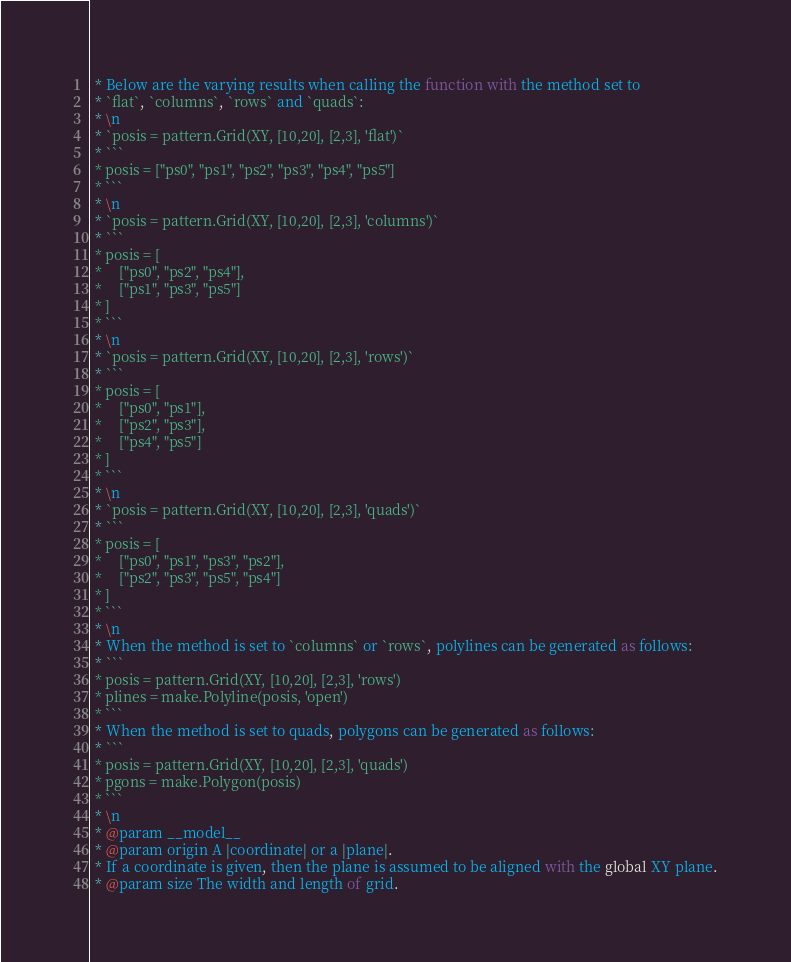<code> <loc_0><loc_0><loc_500><loc_500><_JavaScript_> * Below are the varying results when calling the function with the method set to
 * `flat`, `columns`, `rows` and `quads`:
 * \n
 * `posis = pattern.Grid(XY, [10,20], [2,3], 'flat')`
 * ```
 * posis = ["ps0", "ps1", "ps2", "ps3", "ps4", "ps5"]
 * ```
 * \n
 * `posis = pattern.Grid(XY, [10,20], [2,3], 'columns')`
 * ```
 * posis = [
 *     ["ps0", "ps2", "ps4"],
 *     ["ps1", "ps3", "ps5"]
 * ]
 * ```
 * \n
 * `posis = pattern.Grid(XY, [10,20], [2,3], 'rows')`
 * ```
 * posis = [
 *     ["ps0", "ps1"],
 *     ["ps2", "ps3"],
 *     ["ps4", "ps5"]
 * ]
 * ```
 * \n
 * `posis = pattern.Grid(XY, [10,20], [2,3], 'quads')`
 * ```
 * posis = [
 *     ["ps0", "ps1", "ps3", "ps2"],
 *     ["ps2", "ps3", "ps5", "ps4"]
 * ]
 * ```
 * \n
 * When the method is set to `columns` or `rows`, polylines can be generated as follows:
 * ```
 * posis = pattern.Grid(XY, [10,20], [2,3], 'rows')
 * plines = make.Polyline(posis, 'open')
 * ```
 * When the method is set to quads, polygons can be generated as follows:
 * ```
 * posis = pattern.Grid(XY, [10,20], [2,3], 'quads')
 * pgons = make.Polygon(posis)
 * ```
 * \n
 * @param __model__
 * @param origin A |coordinate| or a |plane|.
 * If a coordinate is given, then the plane is assumed to be aligned with the global XY plane.
 * @param size The width and length of grid.</code> 